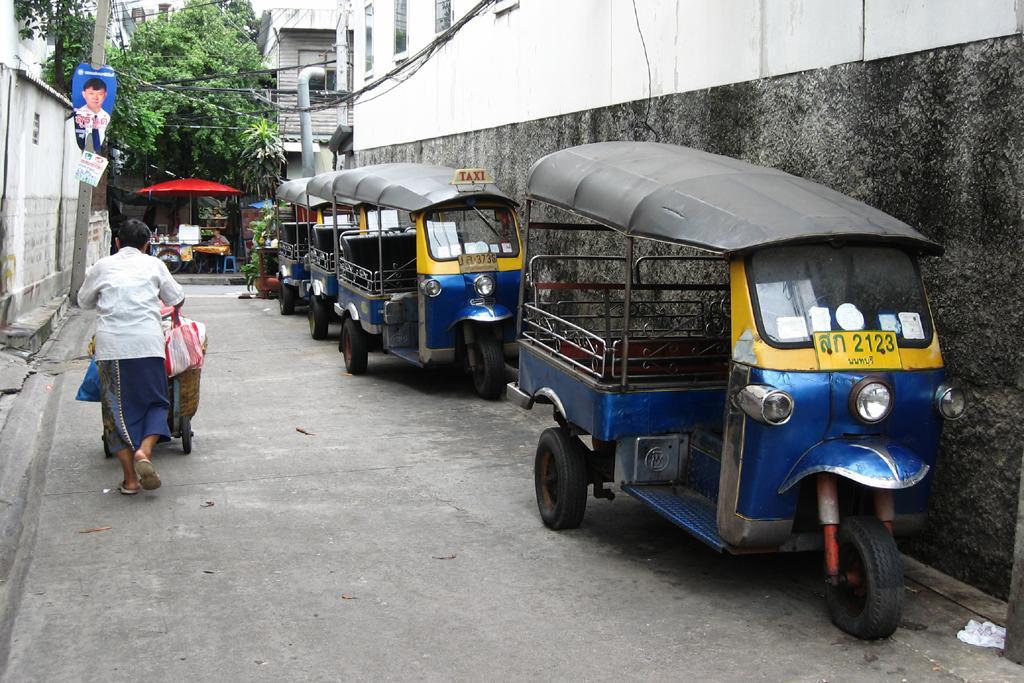Could you give a brief overview of what you see in this image? In this image I can see the road. On the road there are many vehicles and I can see the person with the trolley. The person is wearing the white and blue color dress. To the side I can see the pole and the wall. In the background there are trees and the building. 